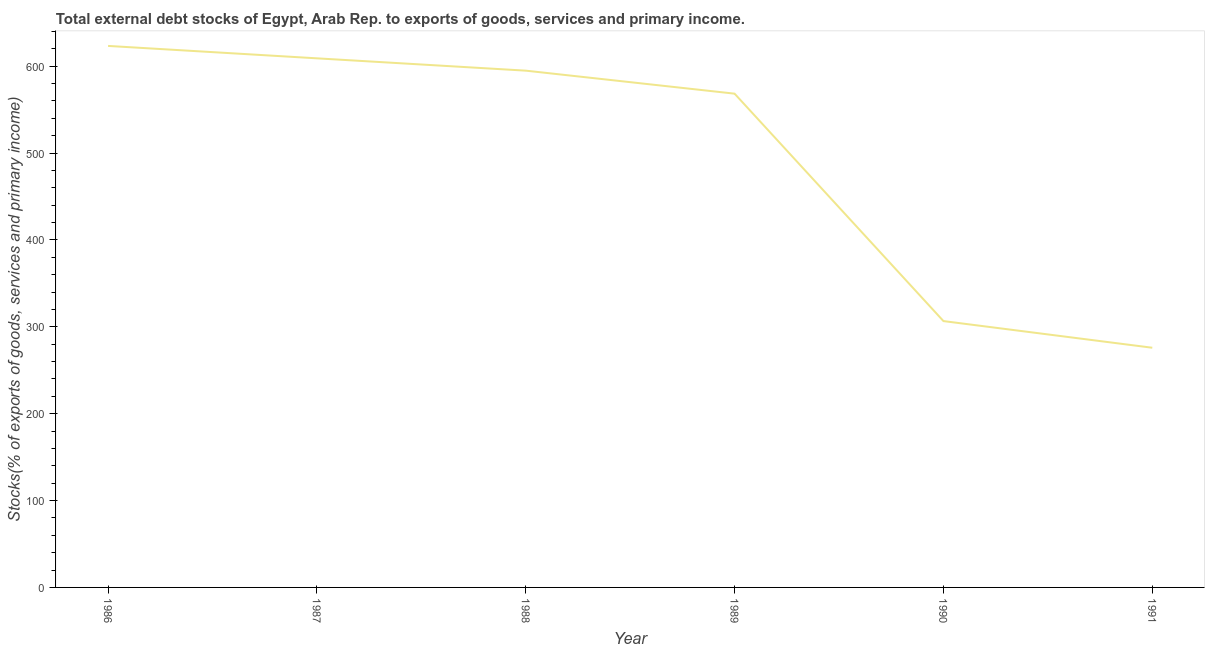What is the external debt stocks in 1990?
Your response must be concise. 306.56. Across all years, what is the maximum external debt stocks?
Provide a short and direct response. 623.28. Across all years, what is the minimum external debt stocks?
Offer a very short reply. 275.87. What is the sum of the external debt stocks?
Offer a terse response. 2977.82. What is the difference between the external debt stocks in 1986 and 1989?
Provide a short and direct response. 54.96. What is the average external debt stocks per year?
Keep it short and to the point. 496.3. What is the median external debt stocks?
Provide a short and direct response. 581.56. Do a majority of the years between 1990 and 1988 (inclusive) have external debt stocks greater than 100 %?
Keep it short and to the point. No. What is the ratio of the external debt stocks in 1987 to that in 1991?
Make the answer very short. 2.21. Is the difference between the external debt stocks in 1988 and 1989 greater than the difference between any two years?
Your answer should be very brief. No. What is the difference between the highest and the second highest external debt stocks?
Keep it short and to the point. 14.29. What is the difference between the highest and the lowest external debt stocks?
Make the answer very short. 347.41. In how many years, is the external debt stocks greater than the average external debt stocks taken over all years?
Offer a terse response. 4. Does the external debt stocks monotonically increase over the years?
Offer a terse response. No. How many lines are there?
Provide a succinct answer. 1. How many years are there in the graph?
Make the answer very short. 6. What is the difference between two consecutive major ticks on the Y-axis?
Your response must be concise. 100. Are the values on the major ticks of Y-axis written in scientific E-notation?
Keep it short and to the point. No. Does the graph contain any zero values?
Your answer should be compact. No. Does the graph contain grids?
Offer a terse response. No. What is the title of the graph?
Provide a succinct answer. Total external debt stocks of Egypt, Arab Rep. to exports of goods, services and primary income. What is the label or title of the X-axis?
Keep it short and to the point. Year. What is the label or title of the Y-axis?
Provide a succinct answer. Stocks(% of exports of goods, services and primary income). What is the Stocks(% of exports of goods, services and primary income) of 1986?
Offer a terse response. 623.28. What is the Stocks(% of exports of goods, services and primary income) in 1987?
Offer a terse response. 608.99. What is the Stocks(% of exports of goods, services and primary income) of 1988?
Offer a terse response. 594.81. What is the Stocks(% of exports of goods, services and primary income) in 1989?
Ensure brevity in your answer.  568.31. What is the Stocks(% of exports of goods, services and primary income) in 1990?
Your answer should be very brief. 306.56. What is the Stocks(% of exports of goods, services and primary income) of 1991?
Your answer should be compact. 275.87. What is the difference between the Stocks(% of exports of goods, services and primary income) in 1986 and 1987?
Keep it short and to the point. 14.29. What is the difference between the Stocks(% of exports of goods, services and primary income) in 1986 and 1988?
Give a very brief answer. 28.47. What is the difference between the Stocks(% of exports of goods, services and primary income) in 1986 and 1989?
Offer a terse response. 54.96. What is the difference between the Stocks(% of exports of goods, services and primary income) in 1986 and 1990?
Your answer should be compact. 316.71. What is the difference between the Stocks(% of exports of goods, services and primary income) in 1986 and 1991?
Provide a short and direct response. 347.41. What is the difference between the Stocks(% of exports of goods, services and primary income) in 1987 and 1988?
Your answer should be very brief. 14.19. What is the difference between the Stocks(% of exports of goods, services and primary income) in 1987 and 1989?
Keep it short and to the point. 40.68. What is the difference between the Stocks(% of exports of goods, services and primary income) in 1987 and 1990?
Ensure brevity in your answer.  302.43. What is the difference between the Stocks(% of exports of goods, services and primary income) in 1987 and 1991?
Provide a short and direct response. 333.12. What is the difference between the Stocks(% of exports of goods, services and primary income) in 1988 and 1989?
Give a very brief answer. 26.49. What is the difference between the Stocks(% of exports of goods, services and primary income) in 1988 and 1990?
Give a very brief answer. 288.24. What is the difference between the Stocks(% of exports of goods, services and primary income) in 1988 and 1991?
Provide a succinct answer. 318.94. What is the difference between the Stocks(% of exports of goods, services and primary income) in 1989 and 1990?
Keep it short and to the point. 261.75. What is the difference between the Stocks(% of exports of goods, services and primary income) in 1989 and 1991?
Keep it short and to the point. 292.45. What is the difference between the Stocks(% of exports of goods, services and primary income) in 1990 and 1991?
Offer a terse response. 30.69. What is the ratio of the Stocks(% of exports of goods, services and primary income) in 1986 to that in 1987?
Offer a terse response. 1.02. What is the ratio of the Stocks(% of exports of goods, services and primary income) in 1986 to that in 1988?
Offer a very short reply. 1.05. What is the ratio of the Stocks(% of exports of goods, services and primary income) in 1986 to that in 1989?
Your answer should be very brief. 1.1. What is the ratio of the Stocks(% of exports of goods, services and primary income) in 1986 to that in 1990?
Offer a very short reply. 2.03. What is the ratio of the Stocks(% of exports of goods, services and primary income) in 1986 to that in 1991?
Your response must be concise. 2.26. What is the ratio of the Stocks(% of exports of goods, services and primary income) in 1987 to that in 1988?
Your answer should be compact. 1.02. What is the ratio of the Stocks(% of exports of goods, services and primary income) in 1987 to that in 1989?
Ensure brevity in your answer.  1.07. What is the ratio of the Stocks(% of exports of goods, services and primary income) in 1987 to that in 1990?
Provide a short and direct response. 1.99. What is the ratio of the Stocks(% of exports of goods, services and primary income) in 1987 to that in 1991?
Make the answer very short. 2.21. What is the ratio of the Stocks(% of exports of goods, services and primary income) in 1988 to that in 1989?
Ensure brevity in your answer.  1.05. What is the ratio of the Stocks(% of exports of goods, services and primary income) in 1988 to that in 1990?
Keep it short and to the point. 1.94. What is the ratio of the Stocks(% of exports of goods, services and primary income) in 1988 to that in 1991?
Provide a succinct answer. 2.16. What is the ratio of the Stocks(% of exports of goods, services and primary income) in 1989 to that in 1990?
Offer a terse response. 1.85. What is the ratio of the Stocks(% of exports of goods, services and primary income) in 1989 to that in 1991?
Your answer should be compact. 2.06. What is the ratio of the Stocks(% of exports of goods, services and primary income) in 1990 to that in 1991?
Keep it short and to the point. 1.11. 